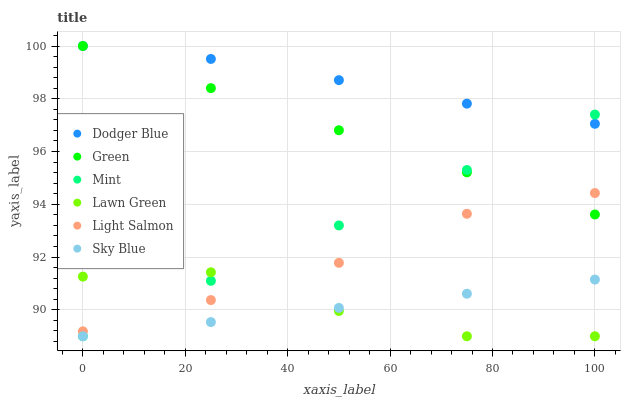Does Sky Blue have the minimum area under the curve?
Answer yes or no. Yes. Does Dodger Blue have the maximum area under the curve?
Answer yes or no. Yes. Does Light Salmon have the minimum area under the curve?
Answer yes or no. No. Does Light Salmon have the maximum area under the curve?
Answer yes or no. No. Is Mint the smoothest?
Answer yes or no. Yes. Is Lawn Green the roughest?
Answer yes or no. Yes. Is Light Salmon the smoothest?
Answer yes or no. No. Is Light Salmon the roughest?
Answer yes or no. No. Does Lawn Green have the lowest value?
Answer yes or no. Yes. Does Light Salmon have the lowest value?
Answer yes or no. No. Does Green have the highest value?
Answer yes or no. Yes. Does Light Salmon have the highest value?
Answer yes or no. No. Is Sky Blue less than Dodger Blue?
Answer yes or no. Yes. Is Dodger Blue greater than Sky Blue?
Answer yes or no. Yes. Does Lawn Green intersect Light Salmon?
Answer yes or no. Yes. Is Lawn Green less than Light Salmon?
Answer yes or no. No. Is Lawn Green greater than Light Salmon?
Answer yes or no. No. Does Sky Blue intersect Dodger Blue?
Answer yes or no. No. 